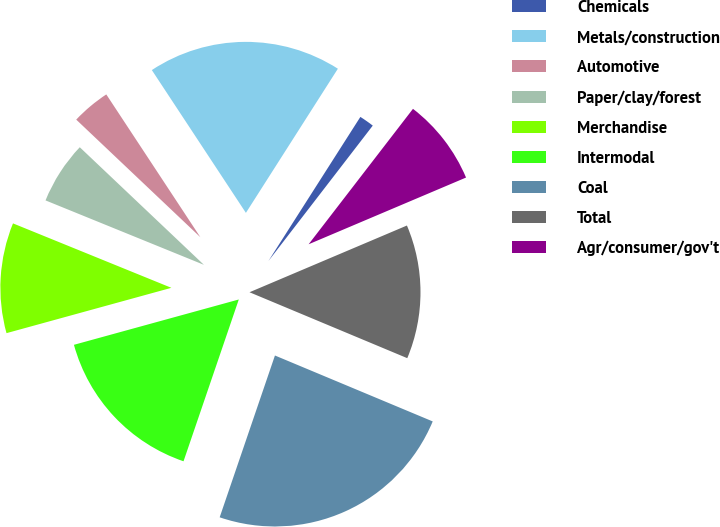Convert chart. <chart><loc_0><loc_0><loc_500><loc_500><pie_chart><fcel>Chemicals<fcel>Metals/construction<fcel>Automotive<fcel>Paper/clay/forest<fcel>Merchandise<fcel>Intermodal<fcel>Coal<fcel>Total<fcel>Agr/consumer/gov't<nl><fcel>1.41%<fcel>18.31%<fcel>3.66%<fcel>5.92%<fcel>10.42%<fcel>15.49%<fcel>23.94%<fcel>12.68%<fcel>8.17%<nl></chart> 